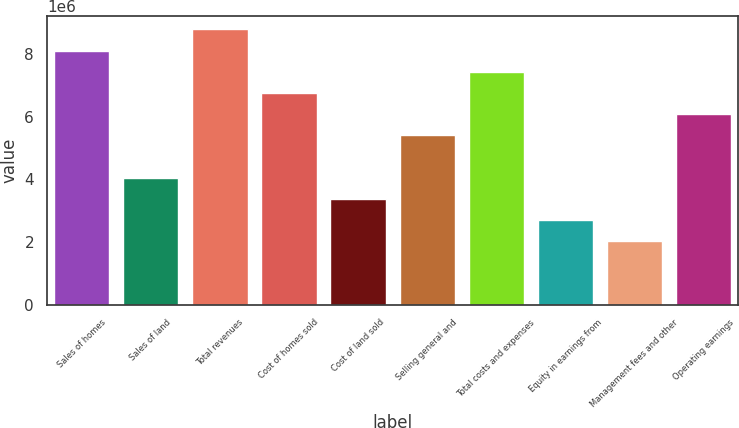Convert chart to OTSL. <chart><loc_0><loc_0><loc_500><loc_500><bar_chart><fcel>Sales of homes<fcel>Sales of land<fcel>Total revenues<fcel>Cost of homes sold<fcel>Cost of land sold<fcel>Selling general and<fcel>Total costs and expenses<fcel>Equity in earnings from<fcel>Management fees and other<fcel>Operating earnings<nl><fcel>8.10156e+06<fcel>4.05078e+06<fcel>8.77669e+06<fcel>6.7513e+06<fcel>3.37566e+06<fcel>5.40104e+06<fcel>7.42643e+06<fcel>2.70053e+06<fcel>2.0254e+06<fcel>6.07617e+06<nl></chart> 